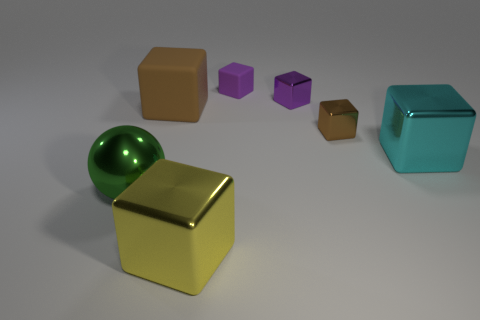Subtract 2 blocks. How many blocks are left? 4 Subtract all cyan blocks. How many blocks are left? 5 Subtract all large brown cubes. How many cubes are left? 5 Subtract all blue cubes. Subtract all green cylinders. How many cubes are left? 6 Add 3 brown objects. How many objects exist? 10 Subtract all spheres. How many objects are left? 6 Add 1 big shiny things. How many big shiny things are left? 4 Add 4 large yellow shiny objects. How many large yellow shiny objects exist? 5 Subtract 2 brown cubes. How many objects are left? 5 Subtract all large blocks. Subtract all brown things. How many objects are left? 2 